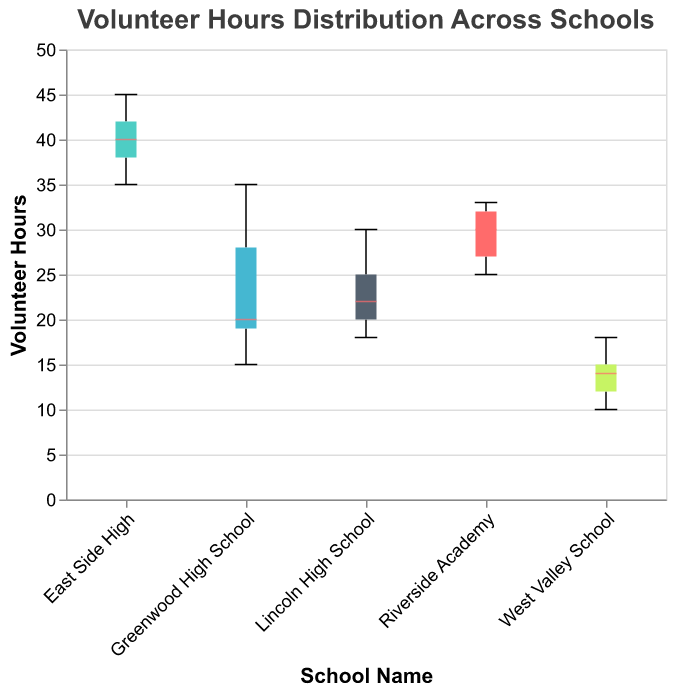What is the title of the box plot? The title is displayed prominently at the top of the figure.
Answer: Volunteer Hours Distribution Across Schools Which school has the highest median volunteer hours? The median is marked by a distinctive line inside each box, and East Side High's box has the highest median.
Answer: East Side High What is the range of volunteer hours for Lincoln High School? Lincoln High School's box plot shows the minimum and maximum values as the whiskers extend from the box. The range is 18 to 30.
Answer: 18 to 30 Which school has the widest range of volunteer hours? By comparing the lengths of the whiskers, Greenwood High School has the widest range, spanning from 15 to 35.
Answer: Greenwood High School What is the median value of volunteer hours at Riverside Academy? The median is marked by a line inside the box of Riverside Academy, positioned at approximately 30 hours.
Answer: 30 Which school has the least variation in volunteer hours? The width of the box and the length of the whiskers indicate the variation. West Valley School has the shortest whiskers and box, implying the least variation.
Answer: West Valley School How do the volunteer hours at Lincoln High School compare to those at East Side High? By contrasting their medians and ranges, East Side High has higher median and maximum values than Lincoln High School.
Answer: East Side High has higher median and maximum values What is the interquartile range (IQR) of volunteer hours for Greenwood High School? The IQR is the range between the first and third quartiles in the box. For Greenwood High School, the IQR is between 19 and 28 hours.
Answer: 9 hours Among all the schools, which one shows the highest single recorded volunteer hour? The maximum value for each school is shown by the top whisker. East Side High has the highest single recorded volunteer hour at 45.
Answer: East Side High Which school has the lowest minimum volunteer hour? The bottom whisker for each box plot represents the minimum. West Valley School has the lowest minimum volunteer hour at 10.
Answer: West Valley School 